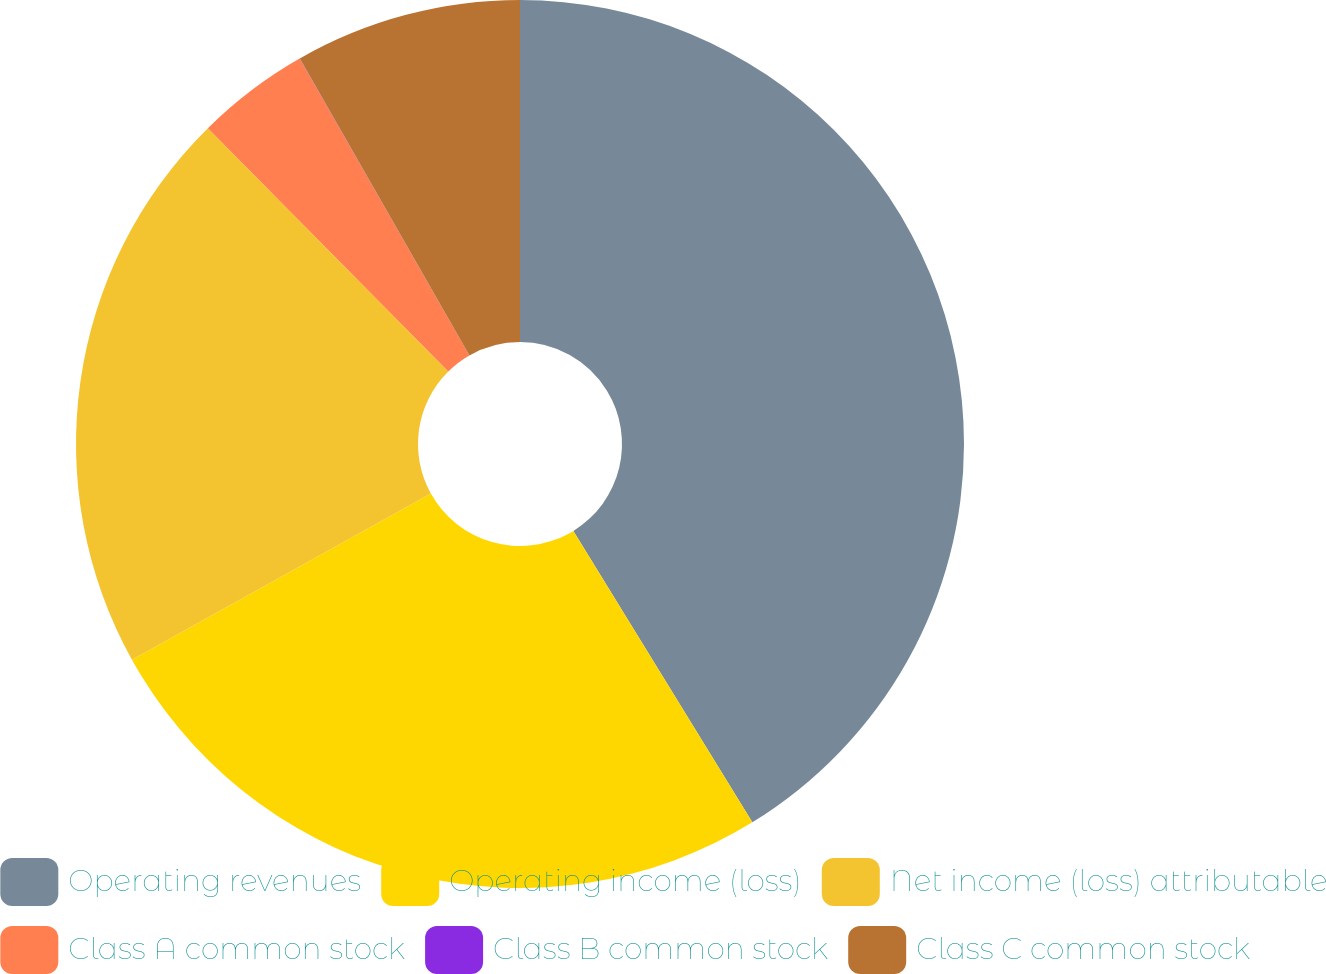Convert chart to OTSL. <chart><loc_0><loc_0><loc_500><loc_500><pie_chart><fcel>Operating revenues<fcel>Operating income (loss)<fcel>Net income (loss) attributable<fcel>Class A common stock<fcel>Class B common stock<fcel>Class C common stock<nl><fcel>41.24%<fcel>25.69%<fcel>20.67%<fcel>4.14%<fcel>0.01%<fcel>8.26%<nl></chart> 